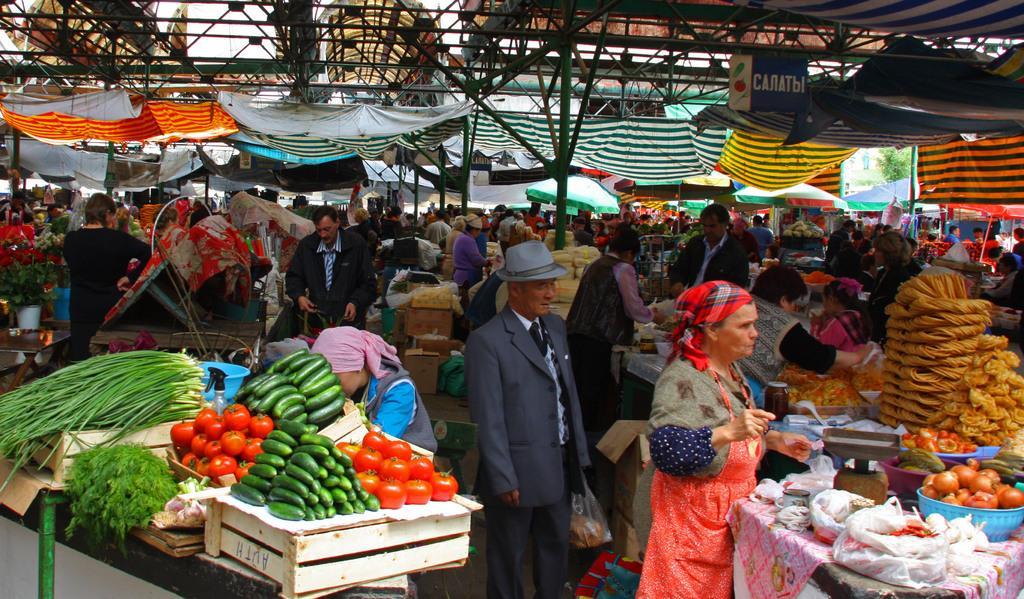Can you describe this image briefly? This image is taken in a market where we can see persons, vegetables, tables, cardboard boxes, poles, tents, food items and weighing machine. 